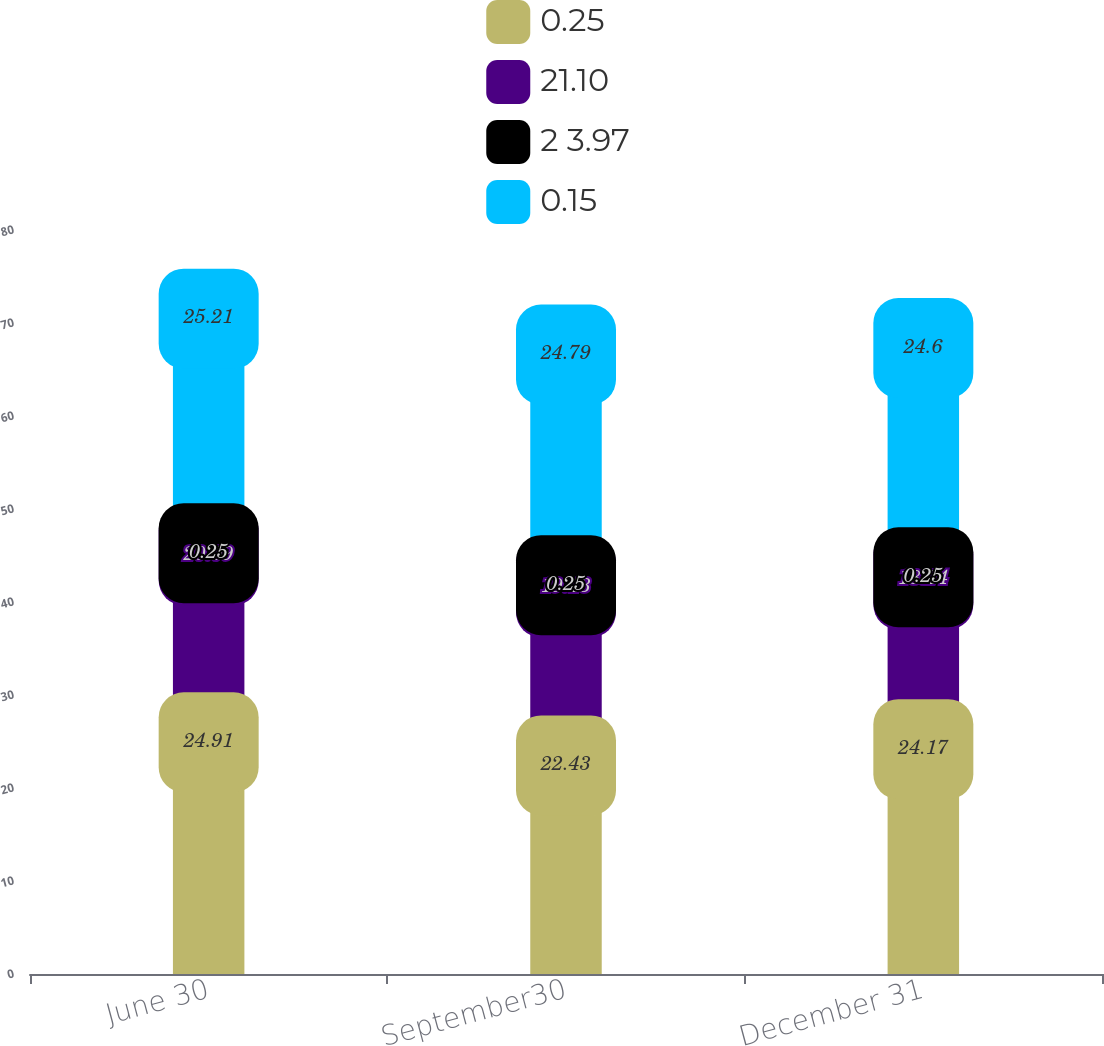Convert chart to OTSL. <chart><loc_0><loc_0><loc_500><loc_500><stacked_bar_chart><ecel><fcel>June 30<fcel>September30<fcel>December 31<nl><fcel>0.25<fcel>24.91<fcel>22.43<fcel>24.17<nl><fcel>21.10<fcel>20.09<fcel>19.13<fcel>18.24<nl><fcel>2 3.97<fcel>0.25<fcel>0.25<fcel>0.25<nl><fcel>0.15<fcel>25.21<fcel>24.79<fcel>24.6<nl></chart> 